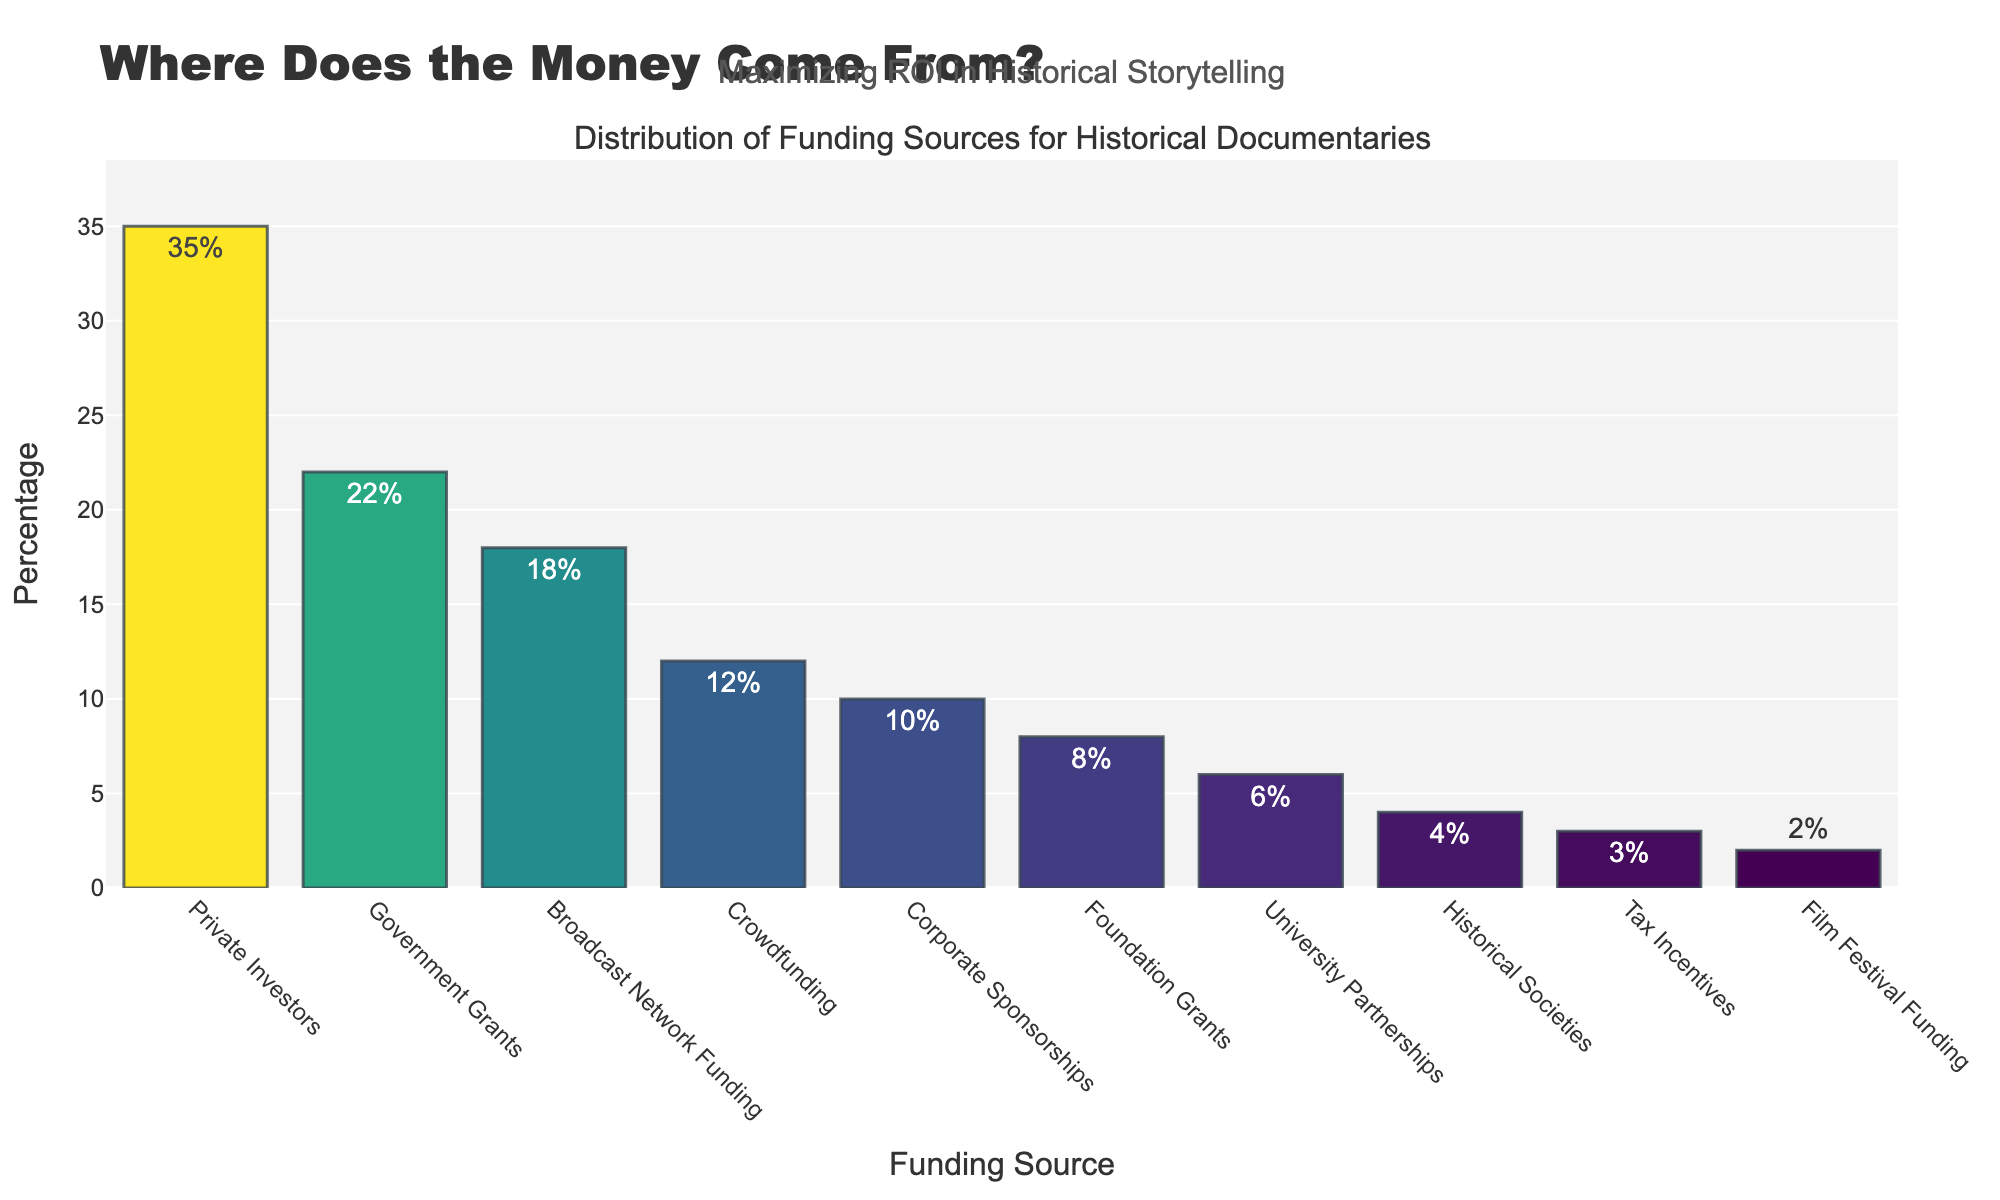What is the most common funding source for historical documentaries? The most common funding source is the one with the highest percentage in the bar chart, which in this case is Private Investors at 35%.
Answer: Private Investors Which funding source contributes a smaller amount than Government Grants but more than Crowdfunding? Look for a bar that has a percentage smaller than 22% (Government Grants) and larger than 12% (Crowdfunding). This bar is Broadcast Network Funding at 18%.
Answer: Broadcast Network Funding What is the combined percentage of Foundation Grants and Corporate Sponsorships? Add the percentages of Foundation Grants (8%) and Corporate Sponsorships (10%). 8% + 10% equals 18%.
Answer: 18% Which funding source has the lowest percentage, and what is that percentage? Identify the bar with the smallest height on the chart. Film Festival Funding has the lowest percentage at 2%.
Answer: Film Festival Funding, 2% How much more funding (in percentage points) do Private Investors contribute compared to Crowdfunding? Subtract the percentage of Crowdfunding (12%) from the percentage of Private Investors (35%). 35% - 12% equals 23%.
Answer: 23% What is the total percentage contributed by Historical Societies, University Partnerships, and Tax Incentives combined? Add the percentages of Historical Societies (4%), University Partnerships (6%), and Tax Incentives (3%). 4% + 6% + 3% equals 13%.
Answer: 13% Is there a funding source that contributes more than twice the percentage of Crowdfunding? Twice the percentage of Crowdfunding is 12% * 2 = 24%. Private Investors at 35% and Government Grants at 22% both exceed this threshold.
Answer: Yes Which funding source is exactly half of the percentage of Broadcast Network Funding? Half of Broadcast Network Funding (18%) is 9%. No funding source contributes exactly 9%, but Foundation Grants and Corporate Sponsorships are close.
Answer: None What is the range of the percentages covered by the funding sources? The range is calculated by subtracting the smallest percentage (Film Festival Funding at 2%) from the largest percentage (Private Investors at 35%). 35% - 2% equals 33%.
Answer: 33% Which funding source has the lighter color between Government Grants and Corporate Sponsorships? The bar for Corporate Sponsorships (10%) is lighter in color because the bars are color-coded by percentage, and higher percentages have darker shades in the Viridis color scale.
Answer: Corporate Sponsorships 